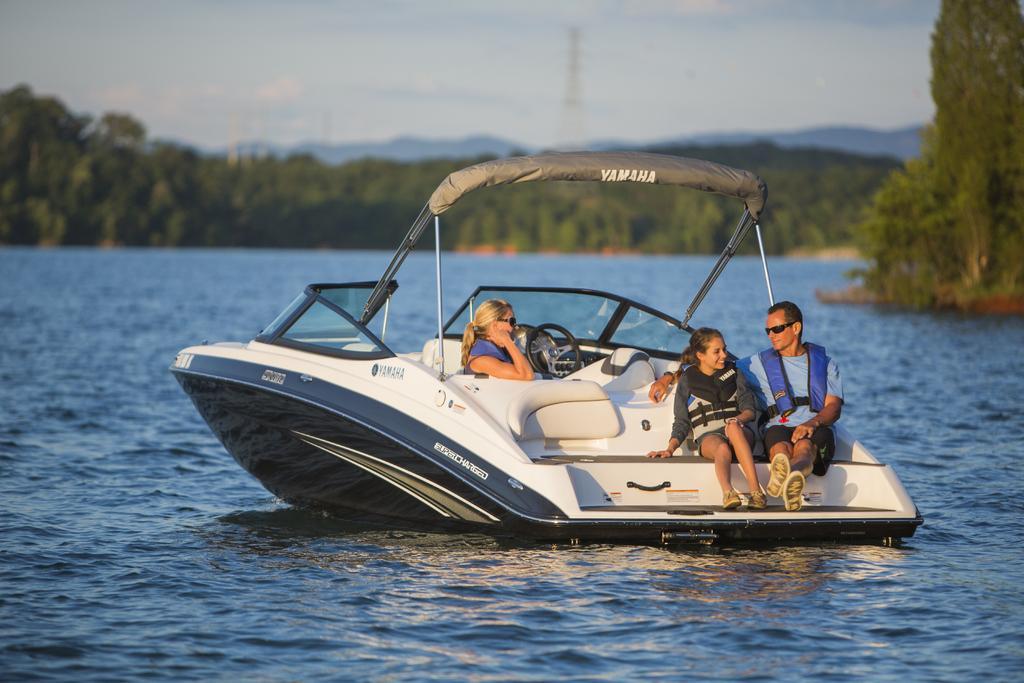Please provide a concise description of this image. In the center of the image there are persons in boat sailing on the water. In the background we can see trees, tower, hill and sky. 